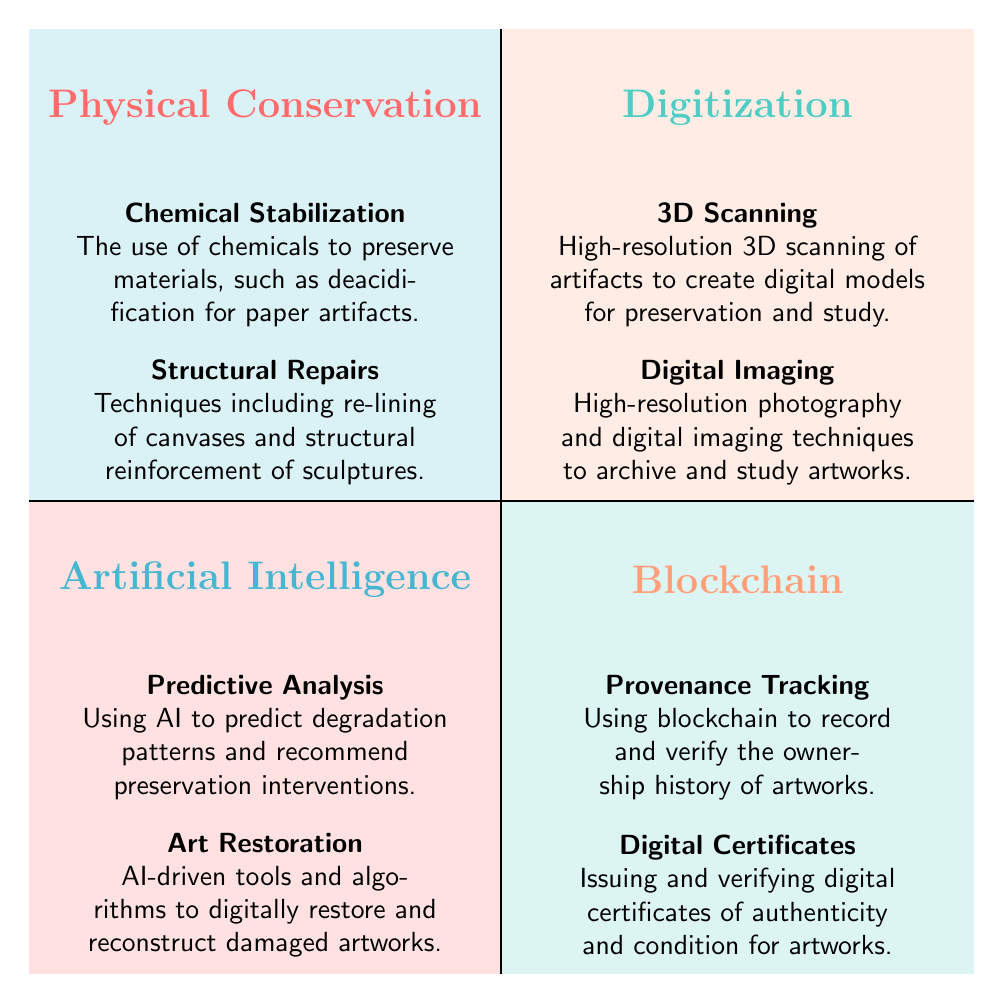What are the two elements listed under Physical Conservation? The diagram displays two elements under the Physical Conservation quadrant: "Chemical Stabilization" and "Structural Repairs." These elements are found in the top left quadrant of the chart.
Answer: Chemical Stabilization, Structural Repairs How many elements are there in the Blockchain quadrant? In the Blockchain quadrant, there are two elements displayed: "Provenance Tracking" and "Digital Certificates." This shows that it contains the same number of elements as the Physical Conservation and Artificial Intelligence quadrants.
Answer: 2 Which quadrant includes AI-driven tools and algorithms? The element "Art Restoration," which refers to AI-driven tools and algorithms, is found in the Artificial Intelligence quadrant located in the bottom left side of the diagram.
Answer: Artificial Intelligence What technique involves high-resolution photography? The technique "Digital Imaging" involves high-resolution photography and is located in the Digitization quadrant. This element captures one of the primary methods used for archiving and studying artworks.
Answer: Digital Imaging Which quadrant comes first (top left) in the diagram? The first quadrant in the top left position of the diagram is Physical Conservation. This is where the methods focusing on the physical aspects of preserving art are represented.
Answer: Physical Conservation Which two preservation techniques are listed under Artificial Intelligence? The two techniques listed under the Artificial Intelligence quadrant are "Predictive Analysis" and "Art Restoration." Both techniques illustrate the application of AI to enhance art preservation.
Answer: Predictive Analysis, Art Restoration What technology is used for provenance tracking? "Blockchain" technology is used for provenance tracking, which is one of the listed elements in the Blockchain quadrant of the diagram. This indicates the relationship between art ownership and digital technology.
Answer: Blockchain How many quadrants does the diagram show? The diagram presents a total of four quadrants, each representing different art preservation techniques in relation to technological advancements.
Answer: 4 What does the term "Chemical Stabilization" refer to? "Chemical Stabilization" refers to the use of chemicals to preserve materials, specifically mentioned as deacidification for paper artifacts. This description is provided in the Physical Conservation quadrant.
Answer: The use of chemicals to preserve materials 